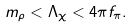<formula> <loc_0><loc_0><loc_500><loc_500>m _ { \rho } < \Lambda _ { \chi } < 4 \pi f _ { \pi } .</formula> 